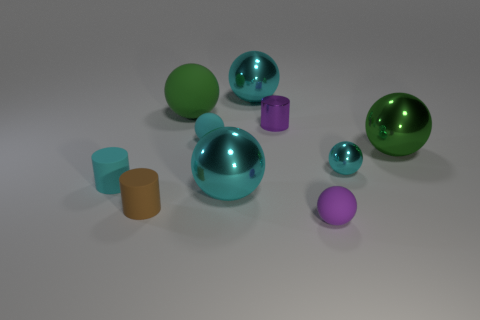How many cyan balls must be subtracted to get 2 cyan balls? 2 Subtract all brown blocks. How many cyan spheres are left? 4 Subtract 3 balls. How many balls are left? 4 Subtract all cyan matte balls. How many balls are left? 6 Subtract all purple balls. How many balls are left? 6 Subtract all brown balls. Subtract all purple blocks. How many balls are left? 7 Subtract all cylinders. How many objects are left? 7 Subtract all purple matte objects. Subtract all purple metallic objects. How many objects are left? 8 Add 1 large shiny balls. How many large shiny balls are left? 4 Add 7 large green shiny things. How many large green shiny things exist? 8 